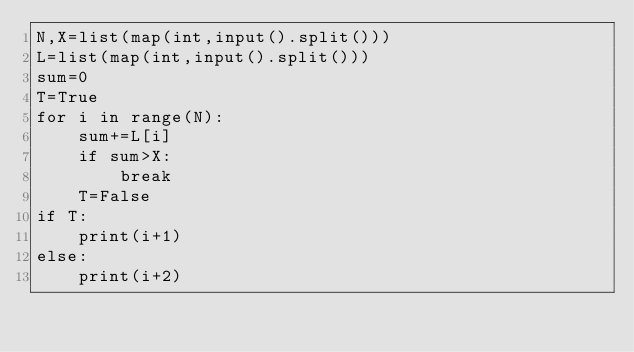Convert code to text. <code><loc_0><loc_0><loc_500><loc_500><_Python_>N,X=list(map(int,input().split()))
L=list(map(int,input().split()))
sum=0
T=True
for i in range(N):
    sum+=L[i]
    if sum>X:
        break
    T=False
if T:
    print(i+1)
else:
    print(i+2)</code> 